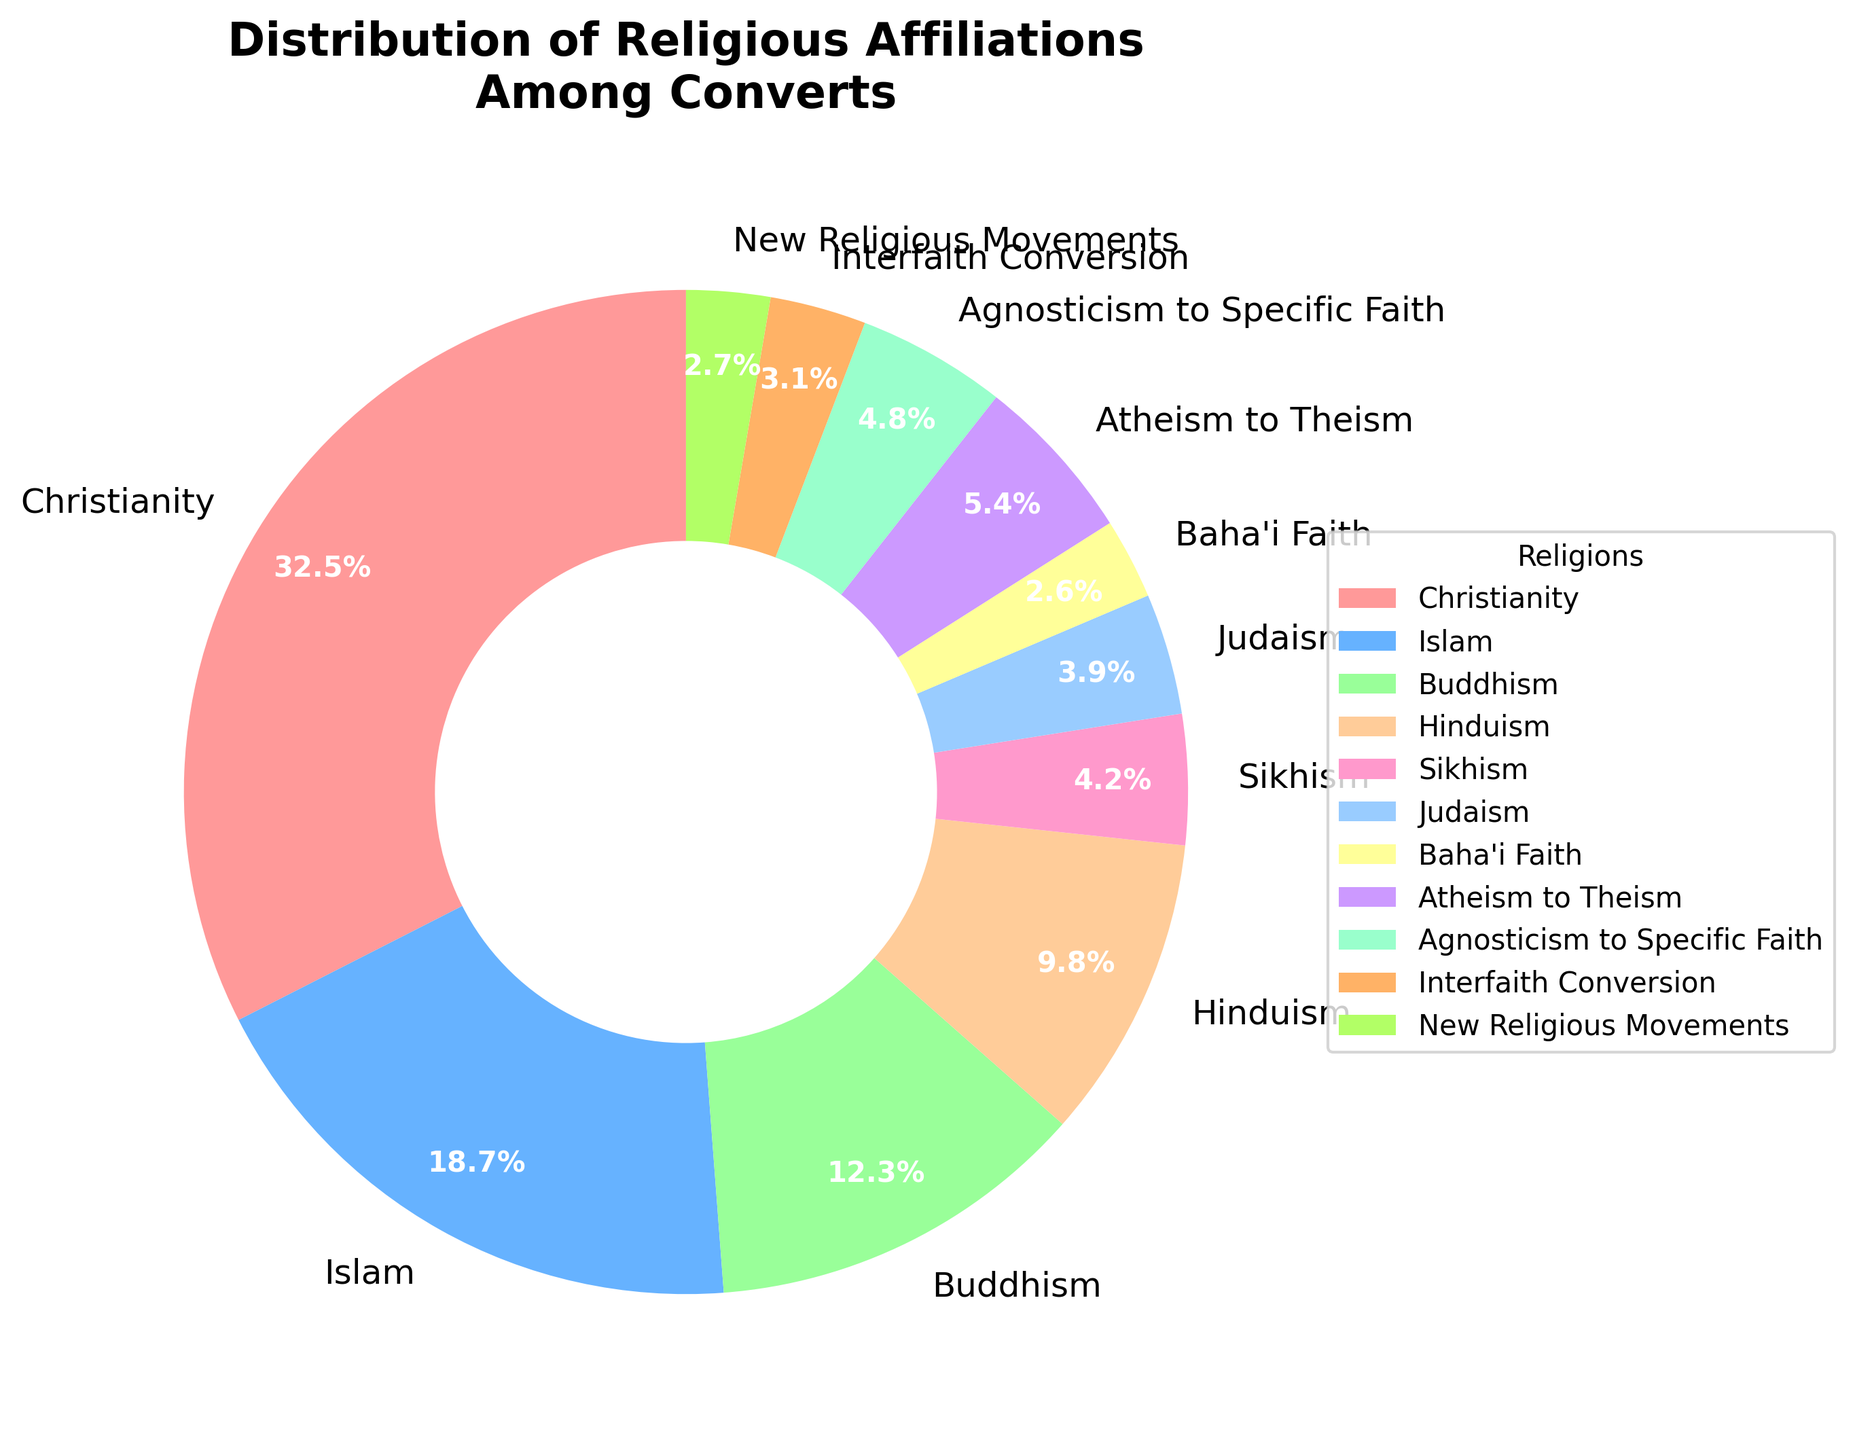What percentage of people converted to Christianity? Look for the slice labeled "Christianity" on the pie chart and read the associated percentage value, which is given as 32.5%.
Answer: 32.5% Among those who experienced conversion, which religion has the smallest percentage? Identify the smallest slice of the pie chart in terms of area, which corresponds to "New Religious Movements" with 2.7%.
Answer: New Religious Movements Are there more converts to Islam or Buddhism? Compare the sizes of the "Islam" and "Buddhism" slices. The "Islam" slice represents 18.7%, and the "Buddhism" slice represents 12.3%. Hence, there are more converts to Islam.
Answer: Islam What is the total percentage for converts to Judaism, Sikhism, and Buddhism combined? Add the percentages for Judaism (3.9%), Sikhism (4.2%), and Buddhism (12.3%): 3.9 + 4.2 + 12.3 = 20.4%.
Answer: 20.4% Which category has the greater percentage: Atheism to Theism or Agnosticism to Specific Faith? Compare the values for "Atheism to Theism" (5.4%) and "Agnosticism to Specific Faith" (4.8%). The "Atheism to Theism" percentage is greater.
Answer: Atheism to Theism How does the percentage of converts from Agnosticism to Specific Faith compare to those involved in Interfaith Conversion and New Religious Movements combined? First, sum the percentages for Interfaith Conversion (3.1%) and New Religious Movements (2.7%): 3.1 + 2.7 = 5.8%. Then, compare this to the "Agnosticism to Specific Faith" value of 4.8%. Since 5.8% is greater than 4.8%, the combination is higher.
Answer: The combination is higher What is the average percentage of converts for the three religions with the highest conversion rates? Identify the top three religions: Christianity (32.5%), Islam (18.7%), and Buddhism (12.3%). Calculate the average: (32.5 + 18.7 + 12.3) / 3 = 63.5 / 3 = 21.17%.
Answer: 21.17% Which slices in the pie chart are visually represented in shades of blue? Look for slices that match the blue color description: "Islam" (18.7%) and "Judaism" (3.9%) are shown in shades of blue (light blue for Islam and a different blue for Judaism).
Answer: Islam and Judaism 